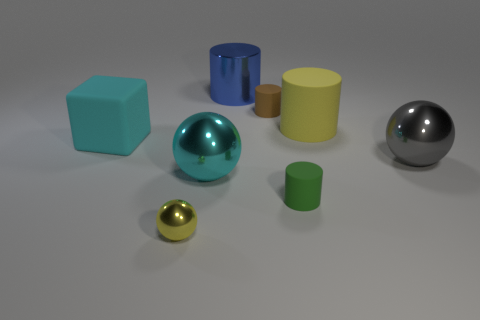Subtract all cyan spheres. How many spheres are left? 2 Add 2 cyan metallic spheres. How many objects exist? 10 Subtract all yellow balls. How many balls are left? 2 Subtract 3 cylinders. How many cylinders are left? 1 Subtract all balls. How many objects are left? 5 Subtract all cyan spheres. How many yellow cylinders are left? 1 Subtract all gray blocks. Subtract all big rubber blocks. How many objects are left? 7 Add 7 large metal spheres. How many large metal spheres are left? 9 Add 6 metal spheres. How many metal spheres exist? 9 Subtract 0 purple blocks. How many objects are left? 8 